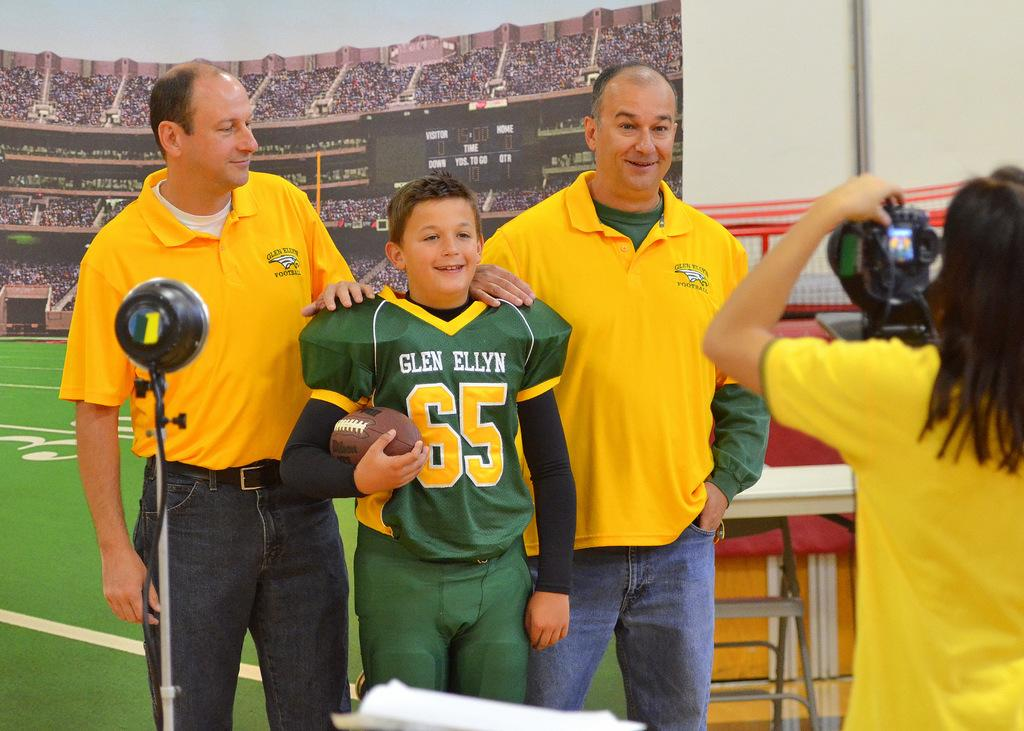<image>
Give a short and clear explanation of the subsequent image. A kid wearing Glen Ellyn's jersey having his picture taken between two men wearing yellow shirts. 